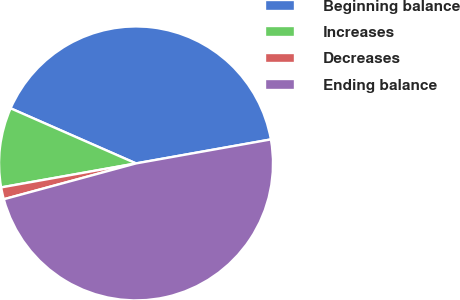Convert chart to OTSL. <chart><loc_0><loc_0><loc_500><loc_500><pie_chart><fcel>Beginning balance<fcel>Increases<fcel>Decreases<fcel>Ending balance<nl><fcel>40.61%<fcel>9.39%<fcel>1.41%<fcel>48.59%<nl></chart> 